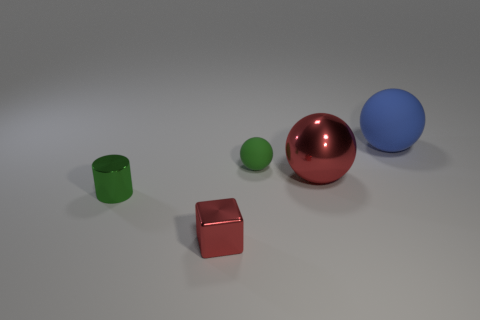Add 5 tiny green objects. How many objects exist? 10 Subtract all spheres. How many objects are left? 2 Subtract 0 green blocks. How many objects are left? 5 Subtract all small blue rubber things. Subtract all large red metallic things. How many objects are left? 4 Add 5 tiny matte spheres. How many tiny matte spheres are left? 6 Add 5 big gray matte cylinders. How many big gray matte cylinders exist? 5 